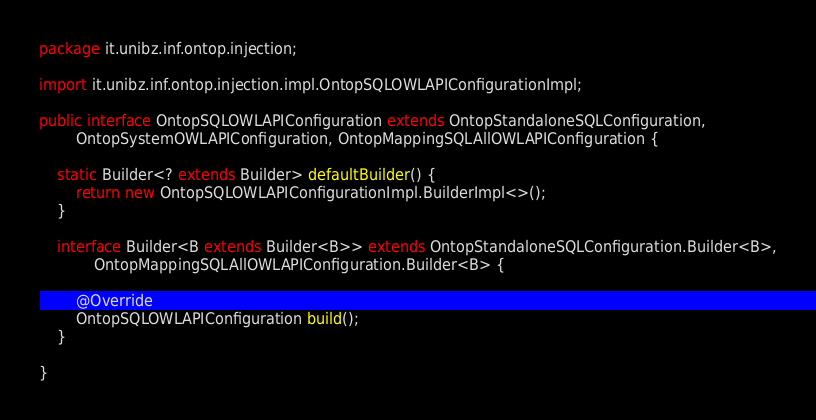<code> <loc_0><loc_0><loc_500><loc_500><_Java_>package it.unibz.inf.ontop.injection;

import it.unibz.inf.ontop.injection.impl.OntopSQLOWLAPIConfigurationImpl;

public interface OntopSQLOWLAPIConfiguration extends OntopStandaloneSQLConfiguration,
        OntopSystemOWLAPIConfiguration, OntopMappingSQLAllOWLAPIConfiguration {

    static Builder<? extends Builder> defaultBuilder() {
        return new OntopSQLOWLAPIConfigurationImpl.BuilderImpl<>();
    }

    interface Builder<B extends Builder<B>> extends OntopStandaloneSQLConfiguration.Builder<B>,
            OntopMappingSQLAllOWLAPIConfiguration.Builder<B> {

        @Override
        OntopSQLOWLAPIConfiguration build();
    }

}
</code> 